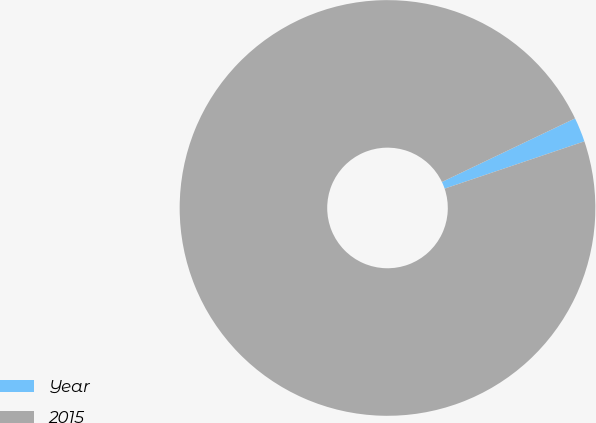Convert chart to OTSL. <chart><loc_0><loc_0><loc_500><loc_500><pie_chart><fcel>Year<fcel>2015<nl><fcel>1.9%<fcel>98.1%<nl></chart> 